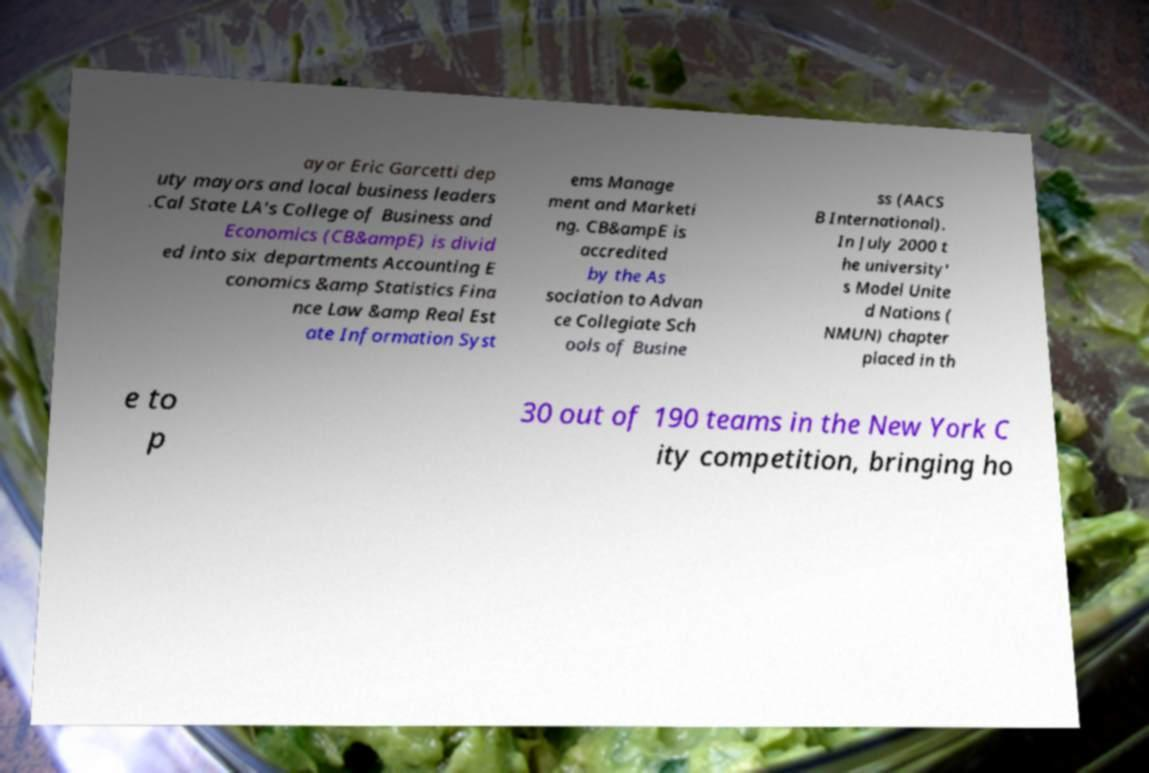Could you assist in decoding the text presented in this image and type it out clearly? ayor Eric Garcetti dep uty mayors and local business leaders .Cal State LA's College of Business and Economics (CB&ampE) is divid ed into six departments Accounting E conomics &amp Statistics Fina nce Law &amp Real Est ate Information Syst ems Manage ment and Marketi ng. CB&ampE is accredited by the As sociation to Advan ce Collegiate Sch ools of Busine ss (AACS B International). In July 2000 t he university' s Model Unite d Nations ( NMUN) chapter placed in th e to p 30 out of 190 teams in the New York C ity competition, bringing ho 